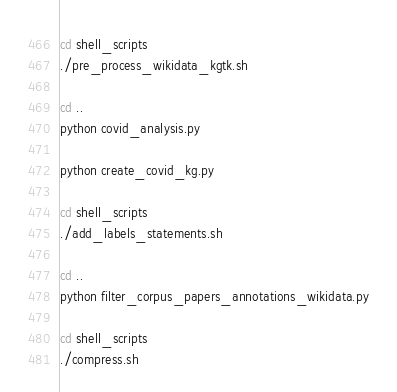<code> <loc_0><loc_0><loc_500><loc_500><_Bash_>cd shell_scripts
./pre_process_wikidata_kgtk.sh

cd ..
python covid_analysis.py

python create_covid_kg.py

cd shell_scripts
./add_labels_statements.sh

cd ..
python filter_corpus_papers_annotations_wikidata.py

cd shell_scripts
./compress.sh</code> 